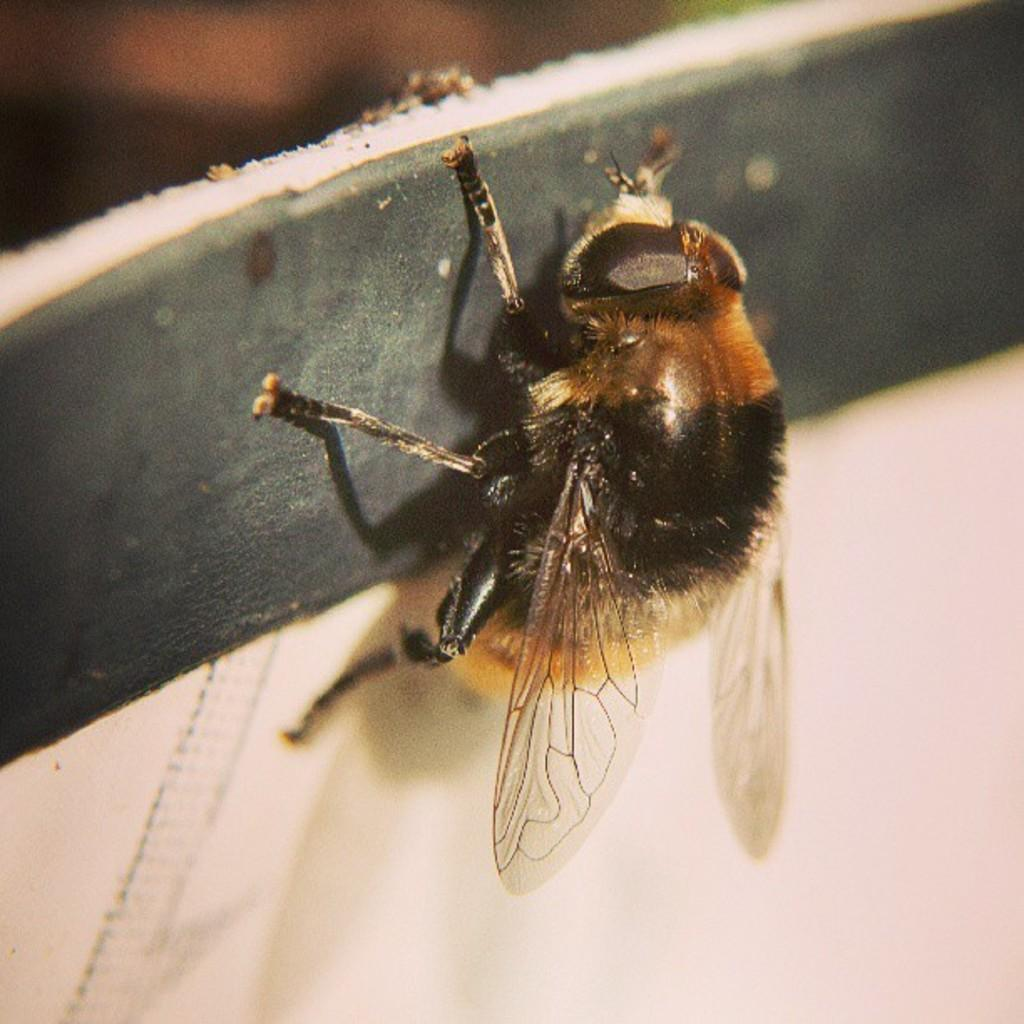What type of creature is present in the image? There is an insect in the image. Can you describe the coloring of the insect? The insect has black and brown coloring. What is the background or surface in the image? The insect is on a black and white surface. What type of horse is the woman riding in the image? There is no horse or woman present in the image; it features an insect on a black and white surface. Can you tell me the name of the lawyer in the image? There is no lawyer present in the image; it features an insect on a black and white surface. 